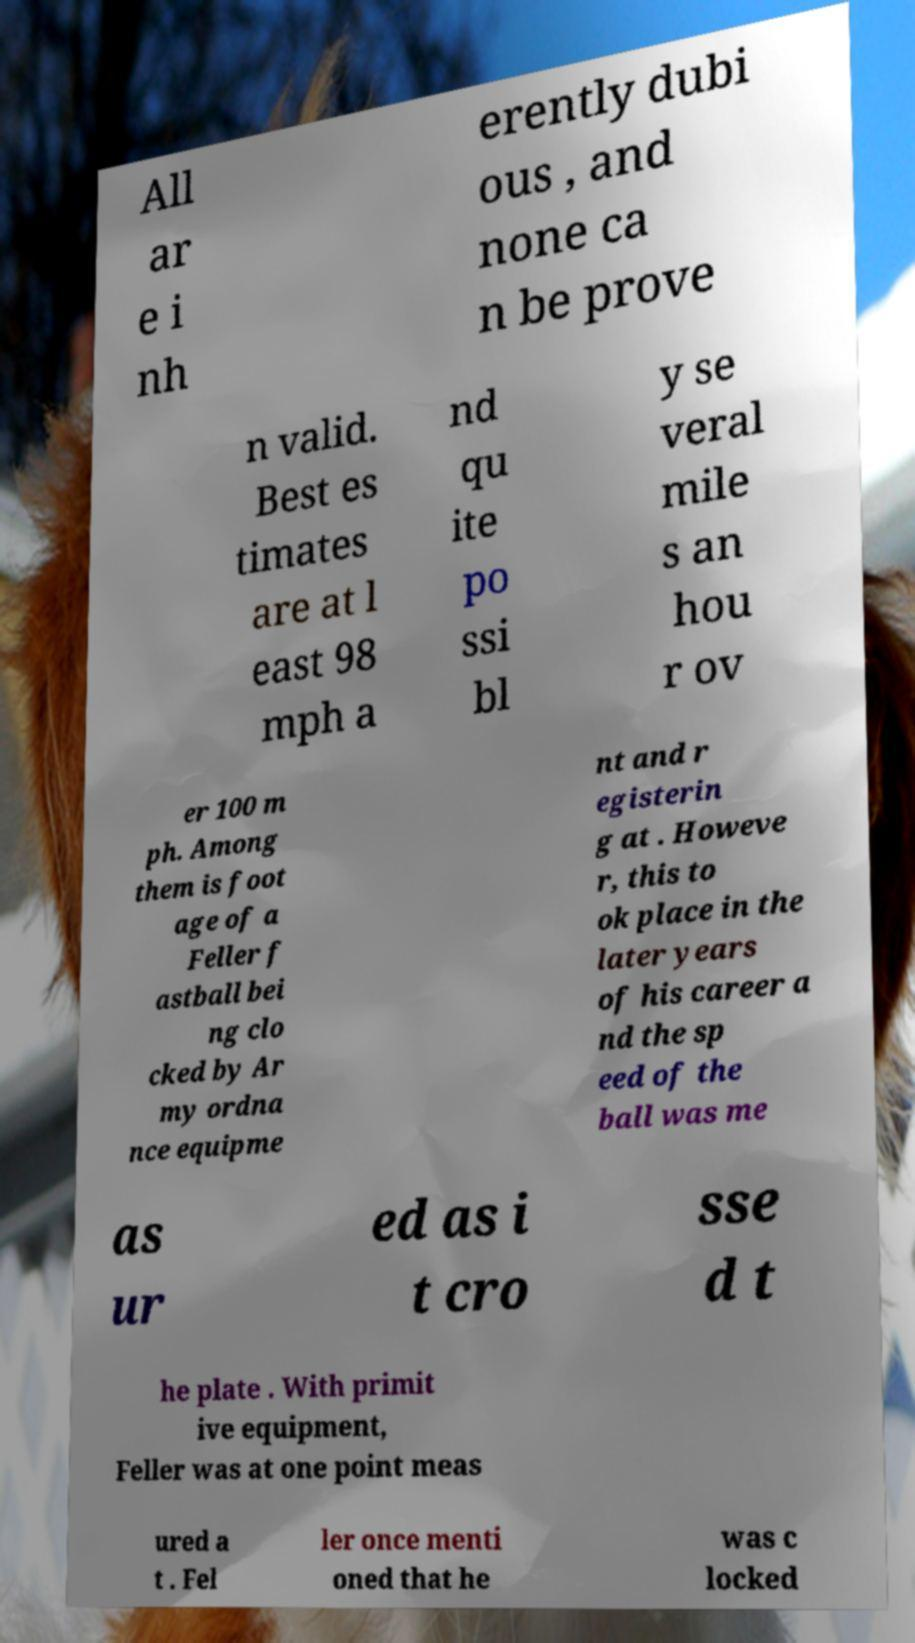Please read and relay the text visible in this image. What does it say? All ar e i nh erently dubi ous , and none ca n be prove n valid. Best es timates are at l east 98 mph a nd qu ite po ssi bl y se veral mile s an hou r ov er 100 m ph. Among them is foot age of a Feller f astball bei ng clo cked by Ar my ordna nce equipme nt and r egisterin g at . Howeve r, this to ok place in the later years of his career a nd the sp eed of the ball was me as ur ed as i t cro sse d t he plate . With primit ive equipment, Feller was at one point meas ured a t . Fel ler once menti oned that he was c locked 